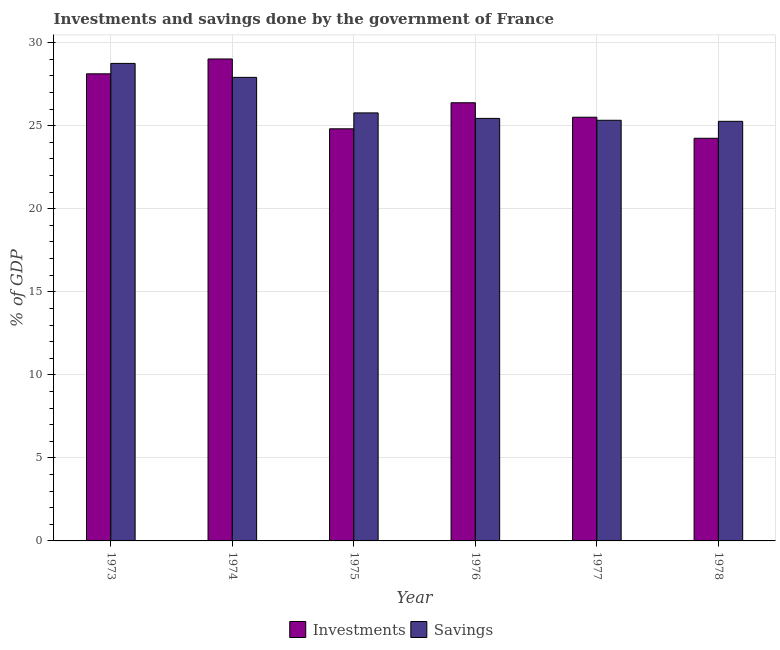How many different coloured bars are there?
Your answer should be compact. 2. How many groups of bars are there?
Your answer should be very brief. 6. Are the number of bars on each tick of the X-axis equal?
Ensure brevity in your answer.  Yes. How many bars are there on the 6th tick from the left?
Ensure brevity in your answer.  2. How many bars are there on the 6th tick from the right?
Give a very brief answer. 2. What is the label of the 2nd group of bars from the left?
Keep it short and to the point. 1974. What is the investments of government in 1976?
Offer a very short reply. 26.38. Across all years, what is the maximum savings of government?
Give a very brief answer. 28.75. Across all years, what is the minimum savings of government?
Provide a succinct answer. 25.26. In which year was the savings of government maximum?
Provide a short and direct response. 1973. In which year was the savings of government minimum?
Keep it short and to the point. 1978. What is the total investments of government in the graph?
Your answer should be very brief. 158.09. What is the difference between the savings of government in 1974 and that in 1975?
Make the answer very short. 2.14. What is the difference between the savings of government in 1973 and the investments of government in 1976?
Offer a terse response. 3.31. What is the average investments of government per year?
Ensure brevity in your answer.  26.35. In the year 1973, what is the difference between the investments of government and savings of government?
Your response must be concise. 0. What is the ratio of the investments of government in 1974 to that in 1977?
Ensure brevity in your answer.  1.14. Is the savings of government in 1975 less than that in 1976?
Ensure brevity in your answer.  No. Is the difference between the investments of government in 1974 and 1975 greater than the difference between the savings of government in 1974 and 1975?
Your answer should be compact. No. What is the difference between the highest and the second highest investments of government?
Your answer should be very brief. 0.89. What is the difference between the highest and the lowest savings of government?
Your answer should be compact. 3.49. What does the 2nd bar from the left in 1973 represents?
Offer a very short reply. Savings. What does the 2nd bar from the right in 1976 represents?
Make the answer very short. Investments. Are all the bars in the graph horizontal?
Make the answer very short. No. How many years are there in the graph?
Provide a succinct answer. 6. Are the values on the major ticks of Y-axis written in scientific E-notation?
Provide a short and direct response. No. How many legend labels are there?
Make the answer very short. 2. How are the legend labels stacked?
Provide a short and direct response. Horizontal. What is the title of the graph?
Make the answer very short. Investments and savings done by the government of France. Does "Current US$" appear as one of the legend labels in the graph?
Your answer should be very brief. No. What is the label or title of the X-axis?
Provide a succinct answer. Year. What is the label or title of the Y-axis?
Your answer should be compact. % of GDP. What is the % of GDP in Investments in 1973?
Make the answer very short. 28.12. What is the % of GDP in Savings in 1973?
Your answer should be very brief. 28.75. What is the % of GDP in Investments in 1974?
Ensure brevity in your answer.  29.02. What is the % of GDP of Savings in 1974?
Your answer should be compact. 27.91. What is the % of GDP of Investments in 1975?
Keep it short and to the point. 24.81. What is the % of GDP of Savings in 1975?
Your answer should be compact. 25.77. What is the % of GDP of Investments in 1976?
Give a very brief answer. 26.38. What is the % of GDP in Savings in 1976?
Give a very brief answer. 25.44. What is the % of GDP in Investments in 1977?
Your answer should be compact. 25.51. What is the % of GDP in Savings in 1977?
Provide a short and direct response. 25.33. What is the % of GDP in Investments in 1978?
Ensure brevity in your answer.  24.24. What is the % of GDP of Savings in 1978?
Provide a short and direct response. 25.26. Across all years, what is the maximum % of GDP of Investments?
Your answer should be very brief. 29.02. Across all years, what is the maximum % of GDP of Savings?
Keep it short and to the point. 28.75. Across all years, what is the minimum % of GDP in Investments?
Your answer should be very brief. 24.24. Across all years, what is the minimum % of GDP of Savings?
Your answer should be compact. 25.26. What is the total % of GDP in Investments in the graph?
Your answer should be compact. 158.09. What is the total % of GDP of Savings in the graph?
Provide a succinct answer. 158.46. What is the difference between the % of GDP of Investments in 1973 and that in 1974?
Your answer should be compact. -0.89. What is the difference between the % of GDP in Savings in 1973 and that in 1974?
Provide a succinct answer. 0.84. What is the difference between the % of GDP in Investments in 1973 and that in 1975?
Make the answer very short. 3.31. What is the difference between the % of GDP of Savings in 1973 and that in 1975?
Offer a very short reply. 2.98. What is the difference between the % of GDP in Investments in 1973 and that in 1976?
Offer a very short reply. 1.74. What is the difference between the % of GDP of Savings in 1973 and that in 1976?
Ensure brevity in your answer.  3.31. What is the difference between the % of GDP of Investments in 1973 and that in 1977?
Provide a short and direct response. 2.61. What is the difference between the % of GDP in Savings in 1973 and that in 1977?
Keep it short and to the point. 3.42. What is the difference between the % of GDP in Investments in 1973 and that in 1978?
Provide a short and direct response. 3.88. What is the difference between the % of GDP of Savings in 1973 and that in 1978?
Keep it short and to the point. 3.49. What is the difference between the % of GDP of Investments in 1974 and that in 1975?
Your answer should be compact. 4.2. What is the difference between the % of GDP in Savings in 1974 and that in 1975?
Give a very brief answer. 2.14. What is the difference between the % of GDP in Investments in 1974 and that in 1976?
Your answer should be compact. 2.64. What is the difference between the % of GDP of Savings in 1974 and that in 1976?
Ensure brevity in your answer.  2.47. What is the difference between the % of GDP in Investments in 1974 and that in 1977?
Make the answer very short. 3.51. What is the difference between the % of GDP of Savings in 1974 and that in 1977?
Offer a very short reply. 2.58. What is the difference between the % of GDP in Investments in 1974 and that in 1978?
Your response must be concise. 4.78. What is the difference between the % of GDP of Savings in 1974 and that in 1978?
Your response must be concise. 2.65. What is the difference between the % of GDP in Investments in 1975 and that in 1976?
Give a very brief answer. -1.57. What is the difference between the % of GDP of Savings in 1975 and that in 1976?
Your answer should be very brief. 0.33. What is the difference between the % of GDP in Investments in 1975 and that in 1977?
Your response must be concise. -0.7. What is the difference between the % of GDP in Savings in 1975 and that in 1977?
Make the answer very short. 0.44. What is the difference between the % of GDP of Investments in 1975 and that in 1978?
Ensure brevity in your answer.  0.57. What is the difference between the % of GDP of Savings in 1975 and that in 1978?
Make the answer very short. 0.51. What is the difference between the % of GDP of Investments in 1976 and that in 1977?
Give a very brief answer. 0.87. What is the difference between the % of GDP in Savings in 1976 and that in 1977?
Provide a succinct answer. 0.11. What is the difference between the % of GDP in Investments in 1976 and that in 1978?
Give a very brief answer. 2.14. What is the difference between the % of GDP in Savings in 1976 and that in 1978?
Keep it short and to the point. 0.18. What is the difference between the % of GDP of Investments in 1977 and that in 1978?
Your answer should be very brief. 1.27. What is the difference between the % of GDP in Savings in 1977 and that in 1978?
Offer a very short reply. 0.06. What is the difference between the % of GDP in Investments in 1973 and the % of GDP in Savings in 1974?
Make the answer very short. 0.21. What is the difference between the % of GDP in Investments in 1973 and the % of GDP in Savings in 1975?
Offer a very short reply. 2.35. What is the difference between the % of GDP of Investments in 1973 and the % of GDP of Savings in 1976?
Ensure brevity in your answer.  2.68. What is the difference between the % of GDP in Investments in 1973 and the % of GDP in Savings in 1977?
Ensure brevity in your answer.  2.8. What is the difference between the % of GDP of Investments in 1973 and the % of GDP of Savings in 1978?
Make the answer very short. 2.86. What is the difference between the % of GDP of Investments in 1974 and the % of GDP of Savings in 1975?
Provide a succinct answer. 3.25. What is the difference between the % of GDP in Investments in 1974 and the % of GDP in Savings in 1976?
Offer a very short reply. 3.58. What is the difference between the % of GDP in Investments in 1974 and the % of GDP in Savings in 1977?
Ensure brevity in your answer.  3.69. What is the difference between the % of GDP in Investments in 1974 and the % of GDP in Savings in 1978?
Your answer should be compact. 3.75. What is the difference between the % of GDP of Investments in 1975 and the % of GDP of Savings in 1976?
Provide a short and direct response. -0.63. What is the difference between the % of GDP in Investments in 1975 and the % of GDP in Savings in 1977?
Make the answer very short. -0.51. What is the difference between the % of GDP in Investments in 1975 and the % of GDP in Savings in 1978?
Keep it short and to the point. -0.45. What is the difference between the % of GDP of Investments in 1976 and the % of GDP of Savings in 1977?
Your answer should be compact. 1.06. What is the difference between the % of GDP in Investments in 1976 and the % of GDP in Savings in 1978?
Your answer should be compact. 1.12. What is the difference between the % of GDP in Investments in 1977 and the % of GDP in Savings in 1978?
Provide a short and direct response. 0.25. What is the average % of GDP in Investments per year?
Keep it short and to the point. 26.35. What is the average % of GDP of Savings per year?
Offer a very short reply. 26.41. In the year 1973, what is the difference between the % of GDP of Investments and % of GDP of Savings?
Your answer should be compact. -0.63. In the year 1974, what is the difference between the % of GDP of Investments and % of GDP of Savings?
Keep it short and to the point. 1.11. In the year 1975, what is the difference between the % of GDP of Investments and % of GDP of Savings?
Your answer should be compact. -0.96. In the year 1976, what is the difference between the % of GDP in Investments and % of GDP in Savings?
Provide a short and direct response. 0.94. In the year 1977, what is the difference between the % of GDP in Investments and % of GDP in Savings?
Provide a succinct answer. 0.18. In the year 1978, what is the difference between the % of GDP of Investments and % of GDP of Savings?
Your answer should be very brief. -1.02. What is the ratio of the % of GDP in Investments in 1973 to that in 1974?
Your answer should be compact. 0.97. What is the ratio of the % of GDP in Savings in 1973 to that in 1974?
Offer a very short reply. 1.03. What is the ratio of the % of GDP of Investments in 1973 to that in 1975?
Make the answer very short. 1.13. What is the ratio of the % of GDP of Savings in 1973 to that in 1975?
Provide a short and direct response. 1.12. What is the ratio of the % of GDP in Investments in 1973 to that in 1976?
Your response must be concise. 1.07. What is the ratio of the % of GDP in Savings in 1973 to that in 1976?
Make the answer very short. 1.13. What is the ratio of the % of GDP of Investments in 1973 to that in 1977?
Your response must be concise. 1.1. What is the ratio of the % of GDP of Savings in 1973 to that in 1977?
Give a very brief answer. 1.14. What is the ratio of the % of GDP in Investments in 1973 to that in 1978?
Offer a terse response. 1.16. What is the ratio of the % of GDP in Savings in 1973 to that in 1978?
Give a very brief answer. 1.14. What is the ratio of the % of GDP of Investments in 1974 to that in 1975?
Ensure brevity in your answer.  1.17. What is the ratio of the % of GDP in Savings in 1974 to that in 1975?
Give a very brief answer. 1.08. What is the ratio of the % of GDP of Investments in 1974 to that in 1976?
Ensure brevity in your answer.  1.1. What is the ratio of the % of GDP in Savings in 1974 to that in 1976?
Your response must be concise. 1.1. What is the ratio of the % of GDP in Investments in 1974 to that in 1977?
Your answer should be very brief. 1.14. What is the ratio of the % of GDP of Savings in 1974 to that in 1977?
Your answer should be very brief. 1.1. What is the ratio of the % of GDP of Investments in 1974 to that in 1978?
Offer a very short reply. 1.2. What is the ratio of the % of GDP in Savings in 1974 to that in 1978?
Your response must be concise. 1.1. What is the ratio of the % of GDP of Investments in 1975 to that in 1976?
Your response must be concise. 0.94. What is the ratio of the % of GDP of Savings in 1975 to that in 1976?
Offer a very short reply. 1.01. What is the ratio of the % of GDP in Investments in 1975 to that in 1977?
Offer a terse response. 0.97. What is the ratio of the % of GDP in Savings in 1975 to that in 1977?
Your response must be concise. 1.02. What is the ratio of the % of GDP in Investments in 1975 to that in 1978?
Provide a succinct answer. 1.02. What is the ratio of the % of GDP in Savings in 1975 to that in 1978?
Give a very brief answer. 1.02. What is the ratio of the % of GDP in Investments in 1976 to that in 1977?
Offer a very short reply. 1.03. What is the ratio of the % of GDP of Investments in 1976 to that in 1978?
Your answer should be very brief. 1.09. What is the ratio of the % of GDP in Savings in 1976 to that in 1978?
Provide a succinct answer. 1.01. What is the ratio of the % of GDP of Investments in 1977 to that in 1978?
Your response must be concise. 1.05. What is the difference between the highest and the second highest % of GDP in Investments?
Your response must be concise. 0.89. What is the difference between the highest and the second highest % of GDP in Savings?
Your response must be concise. 0.84. What is the difference between the highest and the lowest % of GDP of Investments?
Provide a succinct answer. 4.78. What is the difference between the highest and the lowest % of GDP of Savings?
Ensure brevity in your answer.  3.49. 